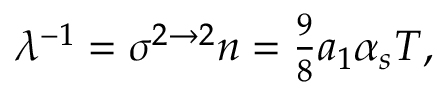<formula> <loc_0><loc_0><loc_500><loc_500>\lambda ^ { - 1 } = \sigma ^ { 2 \to 2 } n = { \frac { 9 } { 8 } } a _ { 1 } \alpha _ { s } T ,</formula> 